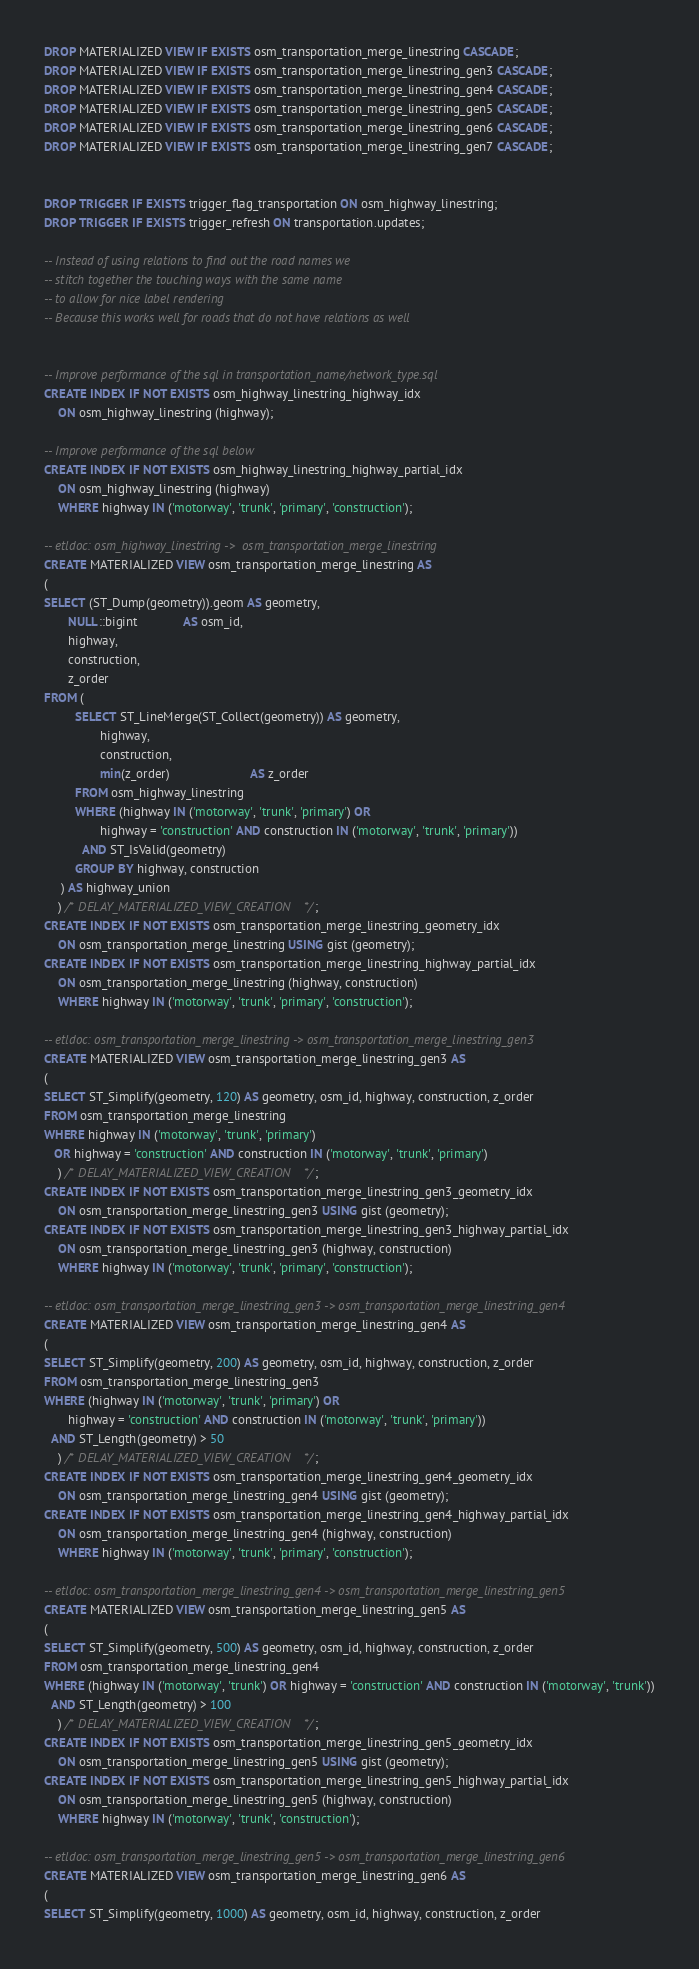Convert code to text. <code><loc_0><loc_0><loc_500><loc_500><_SQL_>DROP MATERIALIZED VIEW IF EXISTS osm_transportation_merge_linestring CASCADE;
DROP MATERIALIZED VIEW IF EXISTS osm_transportation_merge_linestring_gen3 CASCADE;
DROP MATERIALIZED VIEW IF EXISTS osm_transportation_merge_linestring_gen4 CASCADE;
DROP MATERIALIZED VIEW IF EXISTS osm_transportation_merge_linestring_gen5 CASCADE;
DROP MATERIALIZED VIEW IF EXISTS osm_transportation_merge_linestring_gen6 CASCADE;
DROP MATERIALIZED VIEW IF EXISTS osm_transportation_merge_linestring_gen7 CASCADE;


DROP TRIGGER IF EXISTS trigger_flag_transportation ON osm_highway_linestring;
DROP TRIGGER IF EXISTS trigger_refresh ON transportation.updates;

-- Instead of using relations to find out the road names we
-- stitch together the touching ways with the same name
-- to allow for nice label rendering
-- Because this works well for roads that do not have relations as well


-- Improve performance of the sql in transportation_name/network_type.sql
CREATE INDEX IF NOT EXISTS osm_highway_linestring_highway_idx
    ON osm_highway_linestring (highway);

-- Improve performance of the sql below
CREATE INDEX IF NOT EXISTS osm_highway_linestring_highway_partial_idx
    ON osm_highway_linestring (highway)
    WHERE highway IN ('motorway', 'trunk', 'primary', 'construction');

-- etldoc: osm_highway_linestring ->  osm_transportation_merge_linestring
CREATE MATERIALIZED VIEW osm_transportation_merge_linestring AS
(
SELECT (ST_Dump(geometry)).geom AS geometry,
       NULL::bigint             AS osm_id,
       highway,
       construction,
       z_order
FROM (
         SELECT ST_LineMerge(ST_Collect(geometry)) AS geometry,
                highway,
                construction,
                min(z_order)                       AS z_order
         FROM osm_highway_linestring
         WHERE (highway IN ('motorway', 'trunk', 'primary') OR
                highway = 'construction' AND construction IN ('motorway', 'trunk', 'primary'))
           AND ST_IsValid(geometry)
         GROUP BY highway, construction
     ) AS highway_union
    ) /* DELAY_MATERIALIZED_VIEW_CREATION */;
CREATE INDEX IF NOT EXISTS osm_transportation_merge_linestring_geometry_idx
    ON osm_transportation_merge_linestring USING gist (geometry);
CREATE INDEX IF NOT EXISTS osm_transportation_merge_linestring_highway_partial_idx
    ON osm_transportation_merge_linestring (highway, construction)
    WHERE highway IN ('motorway', 'trunk', 'primary', 'construction');

-- etldoc: osm_transportation_merge_linestring -> osm_transportation_merge_linestring_gen3
CREATE MATERIALIZED VIEW osm_transportation_merge_linestring_gen3 AS
(
SELECT ST_Simplify(geometry, 120) AS geometry, osm_id, highway, construction, z_order
FROM osm_transportation_merge_linestring
WHERE highway IN ('motorway', 'trunk', 'primary')
   OR highway = 'construction' AND construction IN ('motorway', 'trunk', 'primary')
    ) /* DELAY_MATERIALIZED_VIEW_CREATION */;
CREATE INDEX IF NOT EXISTS osm_transportation_merge_linestring_gen3_geometry_idx
    ON osm_transportation_merge_linestring_gen3 USING gist (geometry);
CREATE INDEX IF NOT EXISTS osm_transportation_merge_linestring_gen3_highway_partial_idx
    ON osm_transportation_merge_linestring_gen3 (highway, construction)
    WHERE highway IN ('motorway', 'trunk', 'primary', 'construction');

-- etldoc: osm_transportation_merge_linestring_gen3 -> osm_transportation_merge_linestring_gen4
CREATE MATERIALIZED VIEW osm_transportation_merge_linestring_gen4 AS
(
SELECT ST_Simplify(geometry, 200) AS geometry, osm_id, highway, construction, z_order
FROM osm_transportation_merge_linestring_gen3
WHERE (highway IN ('motorway', 'trunk', 'primary') OR
       highway = 'construction' AND construction IN ('motorway', 'trunk', 'primary'))
  AND ST_Length(geometry) > 50
    ) /* DELAY_MATERIALIZED_VIEW_CREATION */;
CREATE INDEX IF NOT EXISTS osm_transportation_merge_linestring_gen4_geometry_idx
    ON osm_transportation_merge_linestring_gen4 USING gist (geometry);
CREATE INDEX IF NOT EXISTS osm_transportation_merge_linestring_gen4_highway_partial_idx
    ON osm_transportation_merge_linestring_gen4 (highway, construction)
    WHERE highway IN ('motorway', 'trunk', 'primary', 'construction');

-- etldoc: osm_transportation_merge_linestring_gen4 -> osm_transportation_merge_linestring_gen5
CREATE MATERIALIZED VIEW osm_transportation_merge_linestring_gen5 AS
(
SELECT ST_Simplify(geometry, 500) AS geometry, osm_id, highway, construction, z_order
FROM osm_transportation_merge_linestring_gen4
WHERE (highway IN ('motorway', 'trunk') OR highway = 'construction' AND construction IN ('motorway', 'trunk'))
  AND ST_Length(geometry) > 100
    ) /* DELAY_MATERIALIZED_VIEW_CREATION */;
CREATE INDEX IF NOT EXISTS osm_transportation_merge_linestring_gen5_geometry_idx
    ON osm_transportation_merge_linestring_gen5 USING gist (geometry);
CREATE INDEX IF NOT EXISTS osm_transportation_merge_linestring_gen5_highway_partial_idx
    ON osm_transportation_merge_linestring_gen5 (highway, construction)
    WHERE highway IN ('motorway', 'trunk', 'construction');

-- etldoc: osm_transportation_merge_linestring_gen5 -> osm_transportation_merge_linestring_gen6
CREATE MATERIALIZED VIEW osm_transportation_merge_linestring_gen6 AS
(
SELECT ST_Simplify(geometry, 1000) AS geometry, osm_id, highway, construction, z_order</code> 